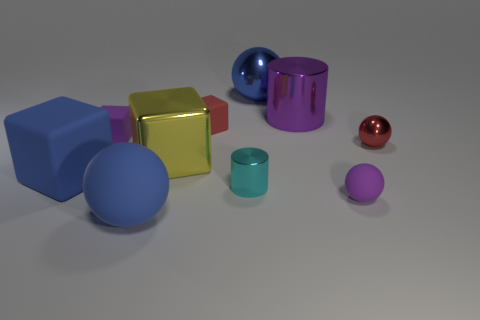How would these objects interact with light in a real-world setting? In a real-world setting, these metallic and glossy objects would reflect and refract light differently. You would see highlights where the light source is directly reflected, shadows cast by the objects, and potential colorful reflections onto each other and the surface they are on, depending on the light's intensity and the environment's context. 